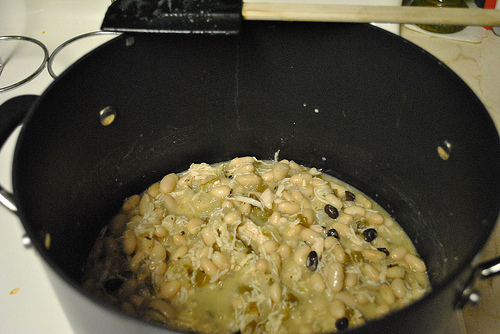<image>
Is the spatula above the pot? Yes. The spatula is positioned above the pot in the vertical space, higher up in the scene. 